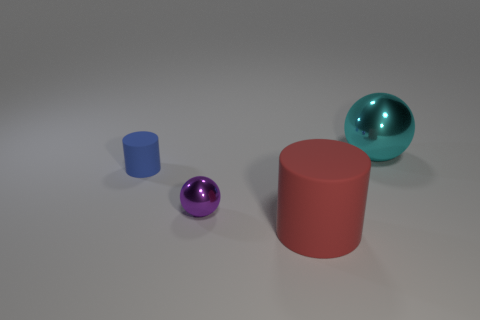Could you describe the lighting and shadows in the scene? The lighting in the scene suggests a single, overhead soft light source, given the soft, diffused shadows cast directly beneath the objects. The absence of harsh shadows and the even illumination suggest an indoor setting with ambient lighting, such as a studio environment. 